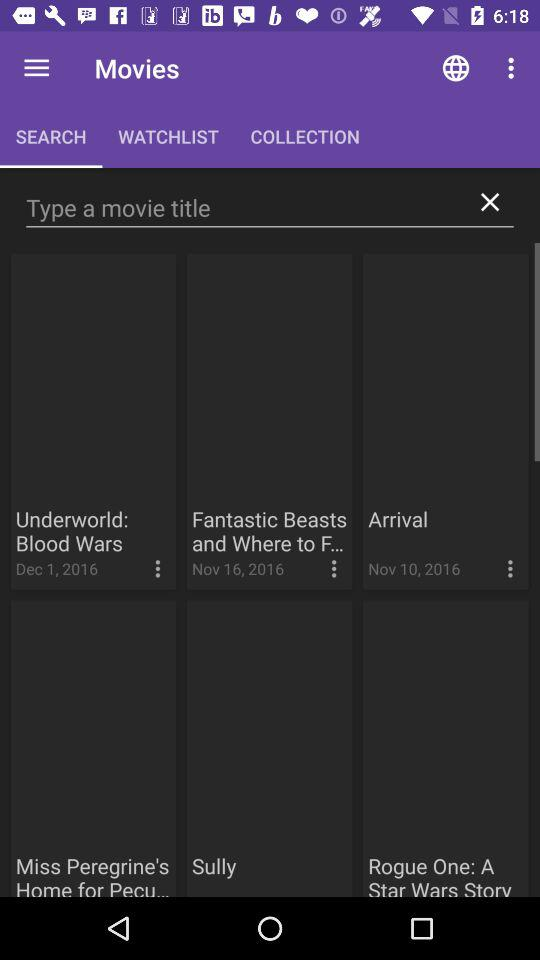What is the upload date of the movie "Arrival"? The date of the upload is November 10, 2016. 